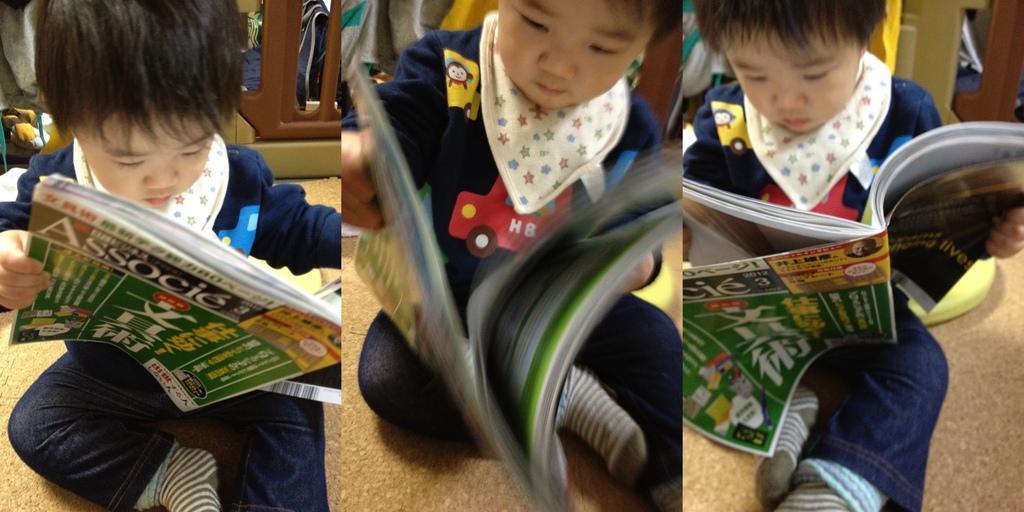How would you summarize this image in a sentence or two? Here this image looks like an college, in which we can see a child is sitting over a place and reading the book present in his hands. 